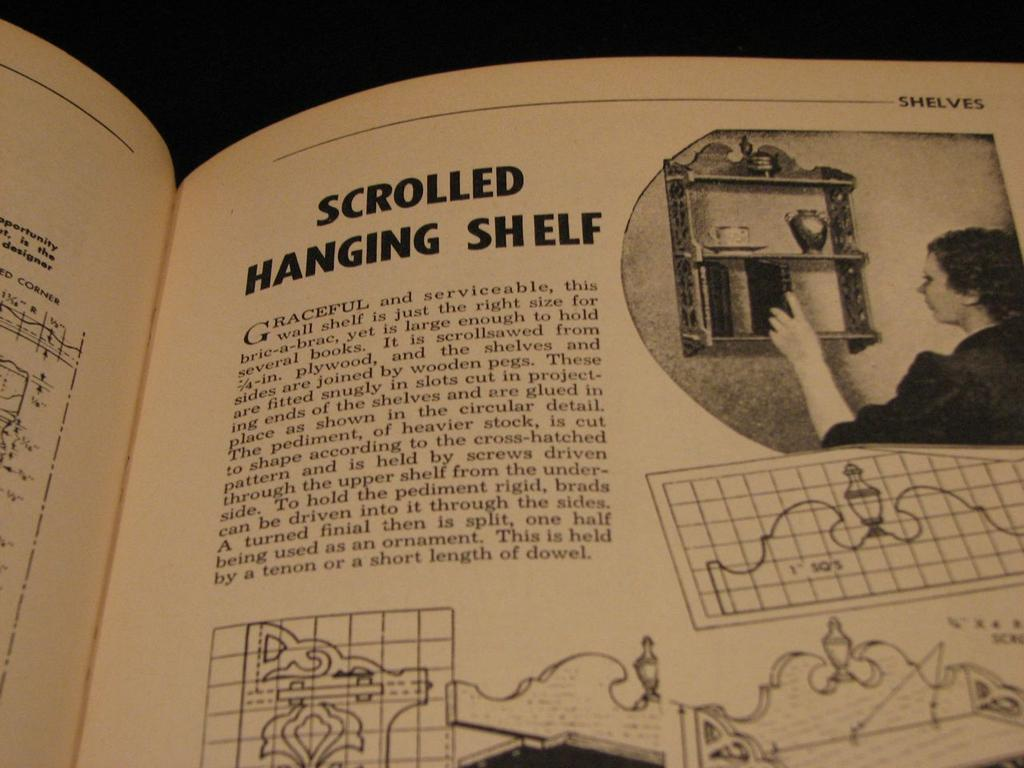<image>
Describe the image concisely. a BOOK ABOUT SCROLLED HANGING SHELF IS OPEN TO A PAGE WITH A WOMEN PUTTING SOMETHING ON A SHELF. 